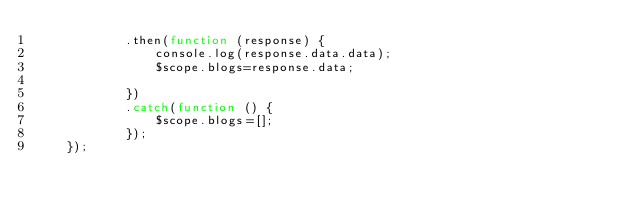<code> <loc_0><loc_0><loc_500><loc_500><_JavaScript_>            .then(function (response) {
                console.log(response.data.data);
                $scope.blogs=response.data;

            })
            .catch(function () {
                $scope.blogs=[];
            });
    });</code> 